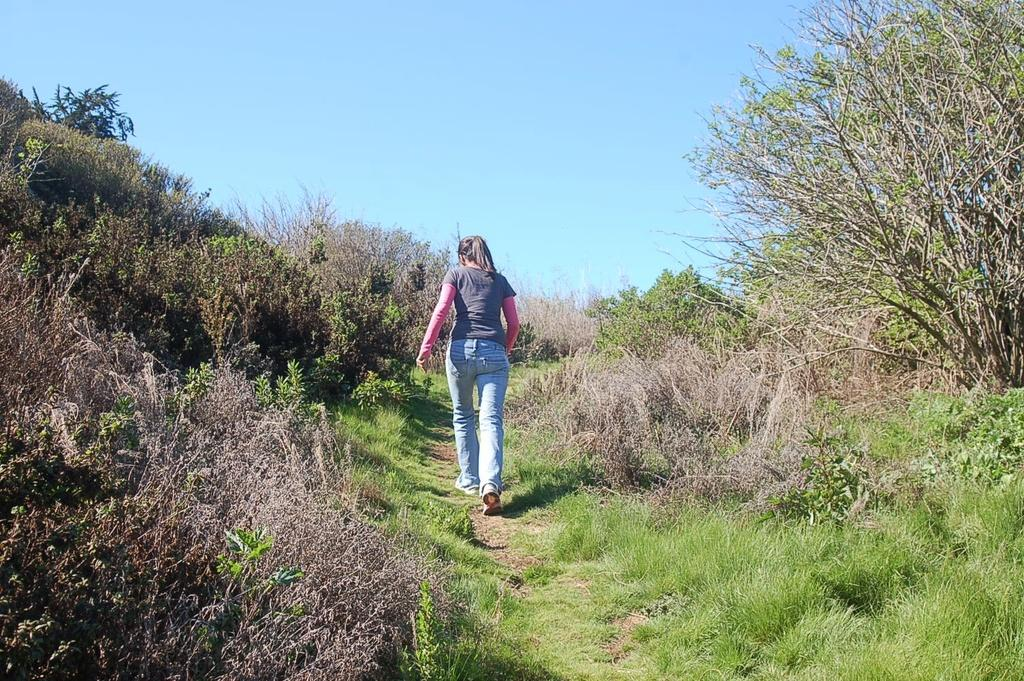What type of surface is visible on the ground in the image? There is grass on the ground in the image. What is the woman in the image doing? There is a woman walking in the image. What can be seen in the distance in the image? There are trees in the background of the image. What subject is the woman teaching in the image? There is no indication in the image that the woman is teaching a subject. How many legs does the woman have in the image? The image does not show the woman's legs, so it cannot be determined how many legs she has. 